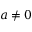Convert formula to latex. <formula><loc_0><loc_0><loc_500><loc_500>a \neq 0</formula> 